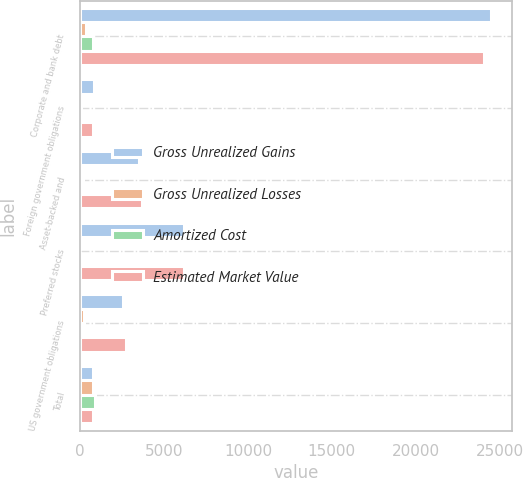Convert chart to OTSL. <chart><loc_0><loc_0><loc_500><loc_500><stacked_bar_chart><ecel><fcel>Corporate and bank debt<fcel>Foreign government obligations<fcel>Asset-backed and<fcel>Preferred stocks<fcel>US government obligations<fcel>Total<nl><fcel>Gross Unrealized Gains<fcel>24496<fcel>825<fcel>3522<fcel>6194<fcel>2535<fcel>800.5<nl><fcel>Gross Unrealized Losses<fcel>373<fcel>5<fcel>202<fcel>13<fcel>209<fcel>802<nl><fcel>Amortized Cost<fcel>780<fcel>31<fcel>42<fcel>3<fcel>7<fcel>863<nl><fcel>Estimated Market Value<fcel>24089<fcel>799<fcel>3682<fcel>6204<fcel>2737<fcel>800.5<nl></chart> 